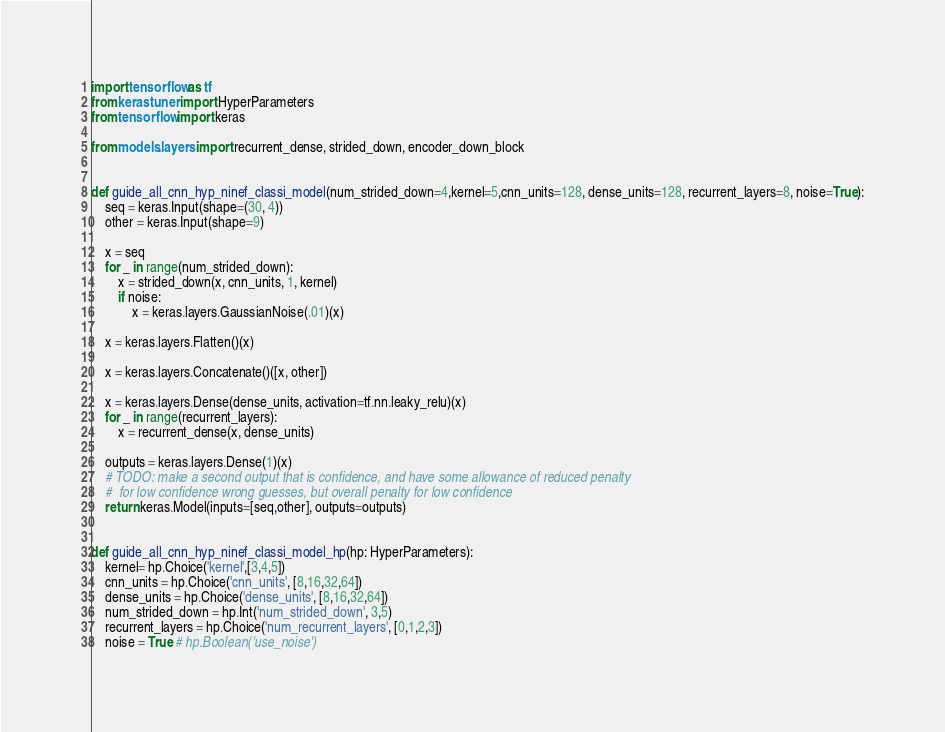<code> <loc_0><loc_0><loc_500><loc_500><_Python_>import tensorflow as tf
from kerastuner import HyperParameters
from tensorflow import keras

from models.layers import recurrent_dense, strided_down, encoder_down_block


def guide_all_cnn_hyp_ninef_classi_model(num_strided_down=4,kernel=5,cnn_units=128, dense_units=128, recurrent_layers=8, noise=True):
    seq = keras.Input(shape=(30, 4))
    other = keras.Input(shape=9)

    x = seq
    for _ in range(num_strided_down):
        x = strided_down(x, cnn_units, 1, kernel)
        if noise:
            x = keras.layers.GaussianNoise(.01)(x)

    x = keras.layers.Flatten()(x)

    x = keras.layers.Concatenate()([x, other])

    x = keras.layers.Dense(dense_units, activation=tf.nn.leaky_relu)(x)
    for _ in range(recurrent_layers):
        x = recurrent_dense(x, dense_units)

    outputs = keras.layers.Dense(1)(x)
    # TODO: make a second output that is confidence, and have some allowance of reduced penalty
    #  for low confidence wrong guesses, but overall penalty for low confidence
    return keras.Model(inputs=[seq,other], outputs=outputs)


def guide_all_cnn_hyp_ninef_classi_model_hp(hp: HyperParameters):
    kernel= hp.Choice('kernel',[3,4,5])
    cnn_units = hp.Choice('cnn_units', [8,16,32,64])
    dense_units = hp.Choice('dense_units', [8,16,32,64])
    num_strided_down = hp.Int('num_strided_down', 3,5)
    recurrent_layers = hp.Choice('num_recurrent_layers', [0,1,2,3])
    noise = True # hp.Boolean('use_noise')
</code> 